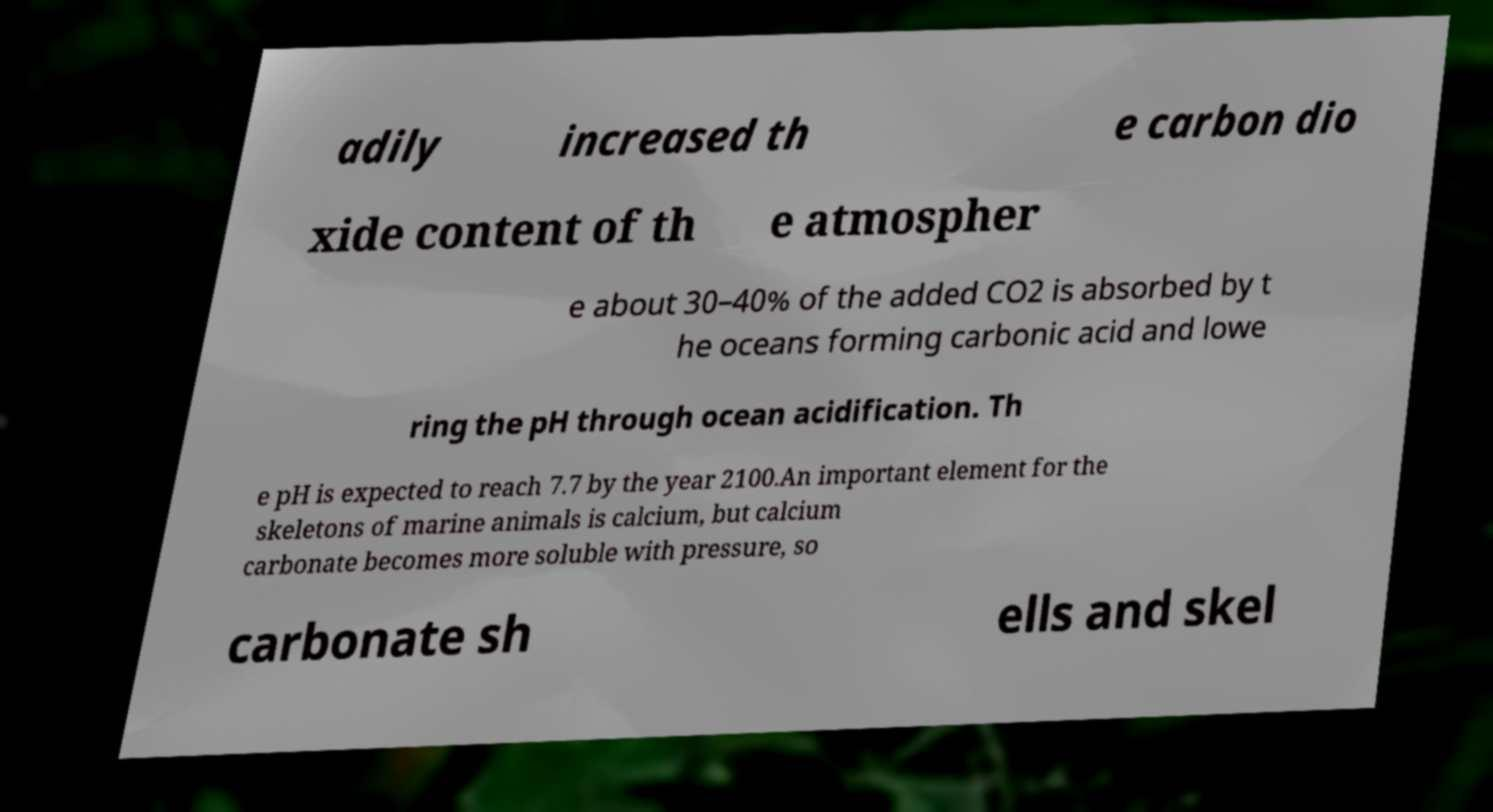Please identify and transcribe the text found in this image. adily increased th e carbon dio xide content of th e atmospher e about 30–40% of the added CO2 is absorbed by t he oceans forming carbonic acid and lowe ring the pH through ocean acidification. Th e pH is expected to reach 7.7 by the year 2100.An important element for the skeletons of marine animals is calcium, but calcium carbonate becomes more soluble with pressure, so carbonate sh ells and skel 